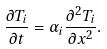Convert formula to latex. <formula><loc_0><loc_0><loc_500><loc_500>\frac { \partial T _ { i } } { \partial t } = \alpha _ { i } \frac { \partial ^ { 2 } T _ { i } } { \partial x ^ { 2 } } .</formula> 